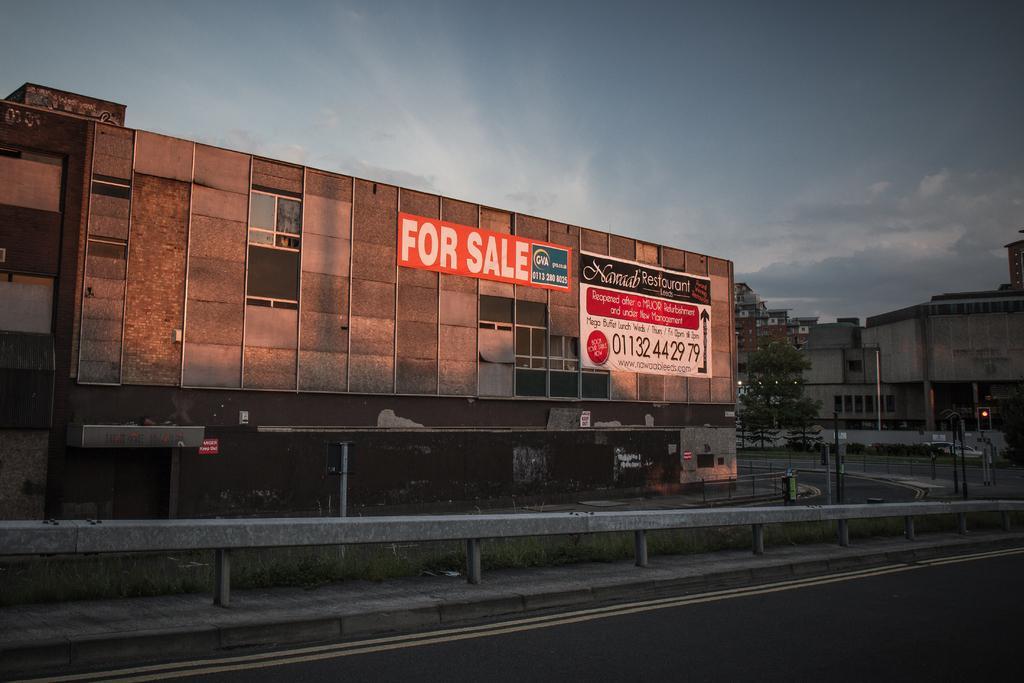How would you summarize this image in a sentence or two? In this image there is a road. There is divider. There is grass. There are buildings. There are trees. There are vehicles. There is a sky. 